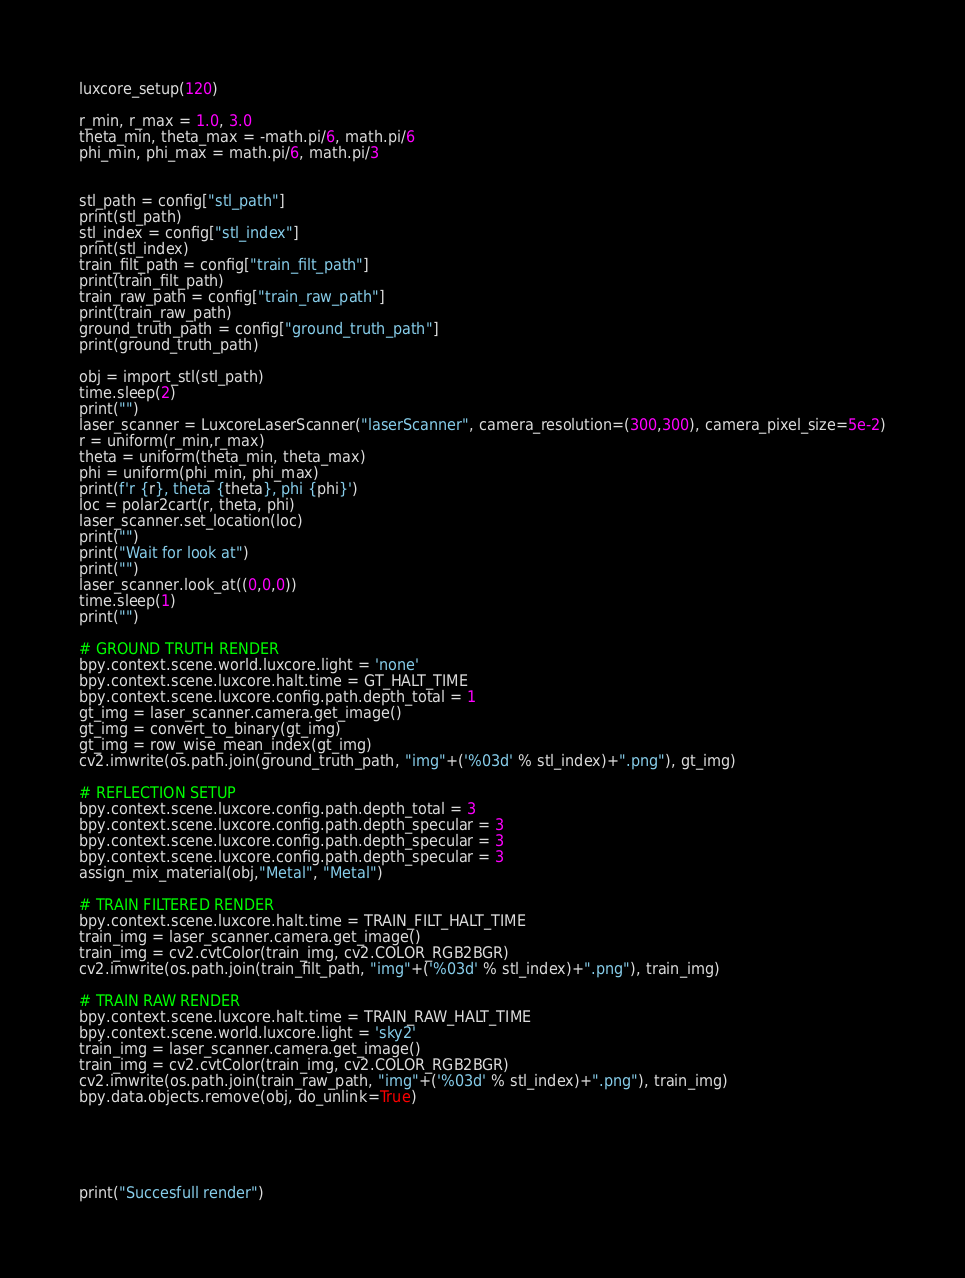<code> <loc_0><loc_0><loc_500><loc_500><_Python_>luxcore_setup(120)

r_min, r_max = 1.0, 3.0
theta_min, theta_max = -math.pi/6, math.pi/6
phi_min, phi_max = math.pi/6, math.pi/3


stl_path = config["stl_path"]
print(stl_path)
stl_index = config["stl_index"]
print(stl_index)
train_filt_path = config["train_filt_path"]
print(train_filt_path)
train_raw_path = config["train_raw_path"]
print(train_raw_path)
ground_truth_path = config["ground_truth_path"]
print(ground_truth_path)

obj = import_stl(stl_path)
time.sleep(2)
print("")
laser_scanner = LuxcoreLaserScanner("laserScanner", camera_resolution=(300,300), camera_pixel_size=5e-2)
r = uniform(r_min,r_max)
theta = uniform(theta_min, theta_max)
phi = uniform(phi_min, phi_max)
print(f'r {r}, theta {theta}, phi {phi}')
loc = polar2cart(r, theta, phi)
laser_scanner.set_location(loc)
print("")
print("Wait for look at")
print("")
laser_scanner.look_at((0,0,0))
time.sleep(1)
print("")

# GROUND TRUTH RENDER
bpy.context.scene.world.luxcore.light = 'none'
bpy.context.scene.luxcore.halt.time = GT_HALT_TIME
bpy.context.scene.luxcore.config.path.depth_total = 1
gt_img = laser_scanner.camera.get_image()
gt_img = convert_to_binary(gt_img)
gt_img = row_wise_mean_index(gt_img)
cv2.imwrite(os.path.join(ground_truth_path, "img"+('%03d' % stl_index)+".png"), gt_img)

# REFLECTION SETUP
bpy.context.scene.luxcore.config.path.depth_total = 3
bpy.context.scene.luxcore.config.path.depth_specular = 3
bpy.context.scene.luxcore.config.path.depth_specular = 3
bpy.context.scene.luxcore.config.path.depth_specular = 3
assign_mix_material(obj,"Metal", "Metal")

# TRAIN FILTERED RENDER
bpy.context.scene.luxcore.halt.time = TRAIN_FILT_HALT_TIME
train_img = laser_scanner.camera.get_image()
train_img = cv2.cvtColor(train_img, cv2.COLOR_RGB2BGR)
cv2.imwrite(os.path.join(train_filt_path, "img"+('%03d' % stl_index)+".png"), train_img)

# TRAIN RAW RENDER
bpy.context.scene.luxcore.halt.time = TRAIN_RAW_HALT_TIME
bpy.context.scene.world.luxcore.light = 'sky2'
train_img = laser_scanner.camera.get_image()
train_img = cv2.cvtColor(train_img, cv2.COLOR_RGB2BGR)
cv2.imwrite(os.path.join(train_raw_path, "img"+('%03d' % stl_index)+".png"), train_img)
bpy.data.objects.remove(obj, do_unlink=True)





print("Succesfull render")
</code> 